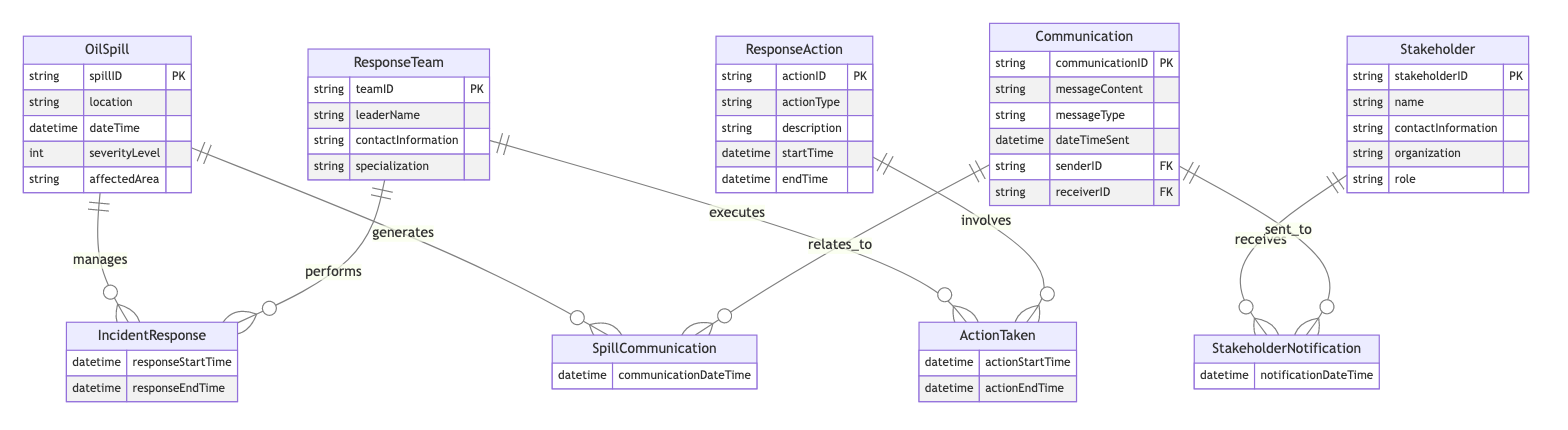What entities are included in the diagram? The diagram includes five entities: OilSpill, ResponseTeam, ResponseAction, Stakeholder, and Communication.
Answer: OilSpill, ResponseTeam, ResponseAction, Stakeholder, Communication How many attributes does the OilSpill entity have? The OilSpill entity has five attributes: spillID, location, dateTime, severityLevel, and affectedArea.
Answer: Five What is the relationship name between OilSpill and ResponseTeam? The relationship name between the OilSpill and ResponseTeam entities is IncidentResponse.
Answer: IncidentResponse Which entity is involved in the ActionTaken relationship? The entities involved in the ActionTaken relationship are ResponseTeam and ResponseAction.
Answer: ResponseTeam, ResponseAction What is the primary key of the Communication entity? The primary key of the Communication entity is communicationID.
Answer: communicationID What action starts the IncidentResponse relationship? The responseStartTime is the action that starts the IncidentResponse relationship.
Answer: responseStartTime How many relationships are there in total within the diagram? The diagram contains four relationships: IncidentResponse, ActionTaken, StakeholderNotification, and SpillCommunication.
Answer: Four What indicates the sender in the Communication entity? The attribute senderID in the Communication entity indicates the sender.
Answer: senderID What type of relationship connects Stakeholder to Communication? The Stakeholder and Communication entities are connected by the StakeholderNotification relationship.
Answer: StakeholderNotification What type of diagram is this? This is an Entity Relationship Diagram (ERD) focusing on crisis management and communication flow.
Answer: Entity Relationship Diagram 